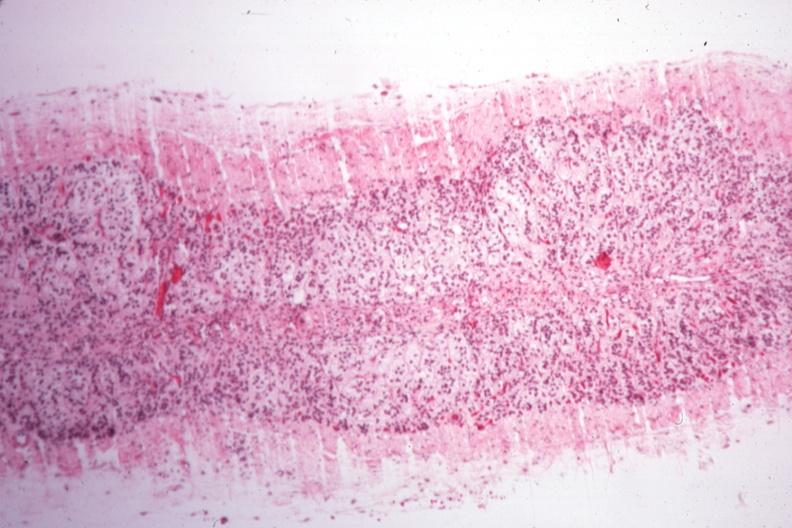what does this image show?
Answer the question using a single word or phrase. Rather good example of atrophy case of type i diabetes with pituitectomy for nine years for retinal lesions 